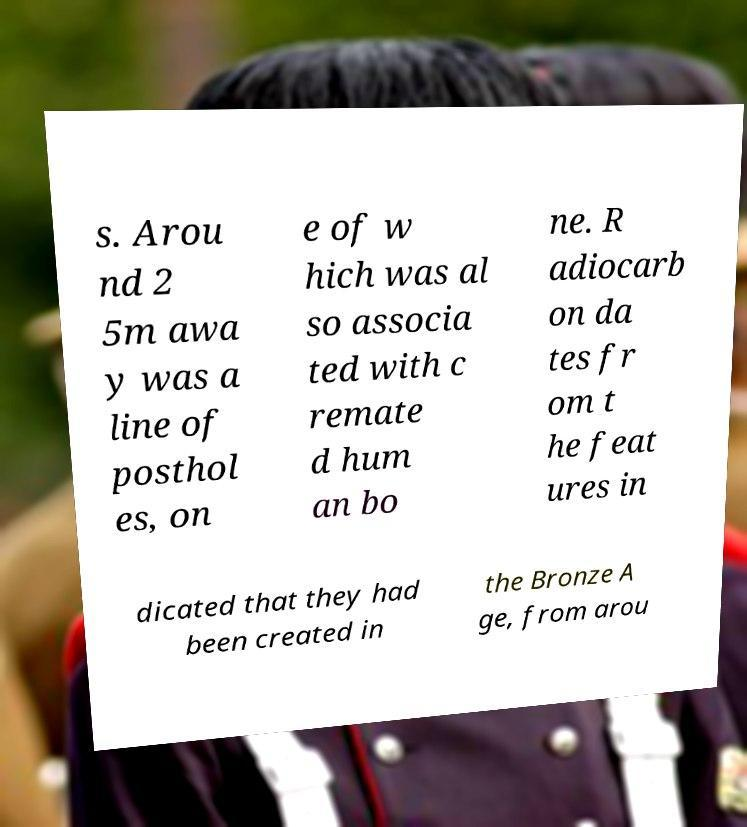Please identify and transcribe the text found in this image. s. Arou nd 2 5m awa y was a line of posthol es, on e of w hich was al so associa ted with c remate d hum an bo ne. R adiocarb on da tes fr om t he feat ures in dicated that they had been created in the Bronze A ge, from arou 